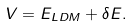Convert formula to latex. <formula><loc_0><loc_0><loc_500><loc_500>V = E _ { L D M } + \delta E .</formula> 